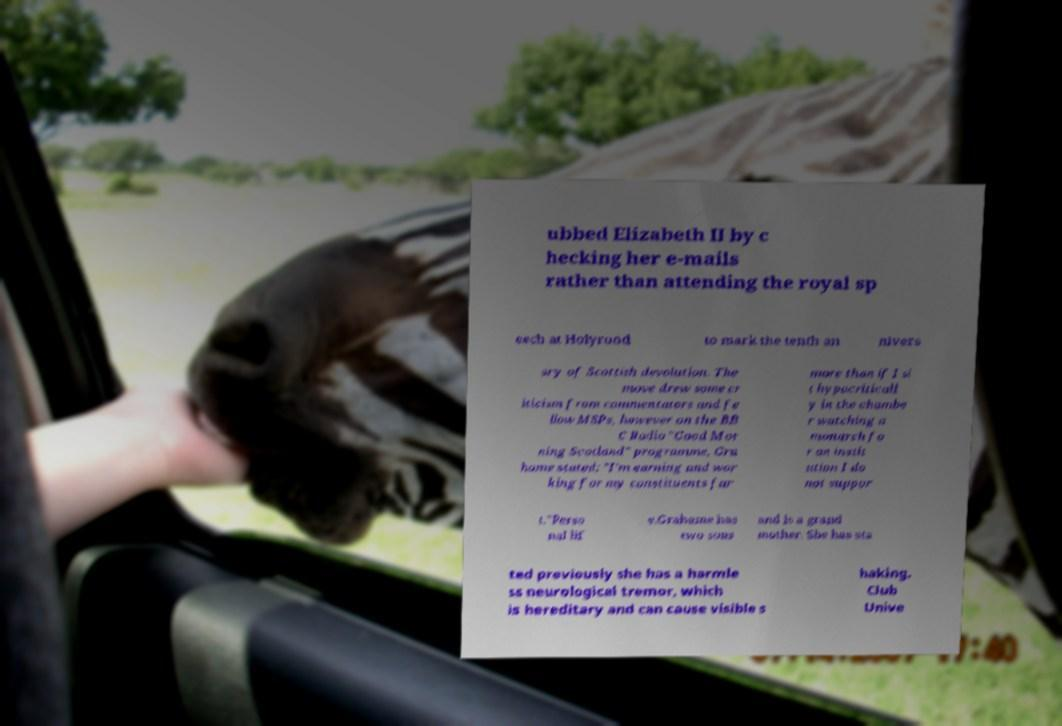Could you assist in decoding the text presented in this image and type it out clearly? ubbed Elizabeth II by c hecking her e-mails rather than attending the royal sp eech at Holyrood to mark the tenth an nivers ary of Scottish devolution. The move drew some cr iticism from commentators and fe llow MSPs, however on the BB C Radio "Good Mor ning Scotland" programme, Gra hame stated: "I'm earning and wor king for my constituents far more than if I si t hypocriticall y in the chambe r watching a monarch fo r an instit ution I do not suppor t."Perso nal lif e.Grahame has two sons and is a grand mother. She has sta ted previously she has a harmle ss neurological tremor, which is hereditary and can cause visible s haking. Club Unive 